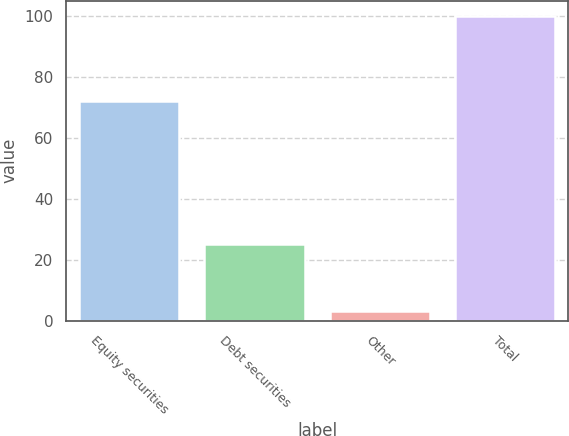Convert chart. <chart><loc_0><loc_0><loc_500><loc_500><bar_chart><fcel>Equity securities<fcel>Debt securities<fcel>Other<fcel>Total<nl><fcel>72<fcel>25<fcel>3<fcel>100<nl></chart> 